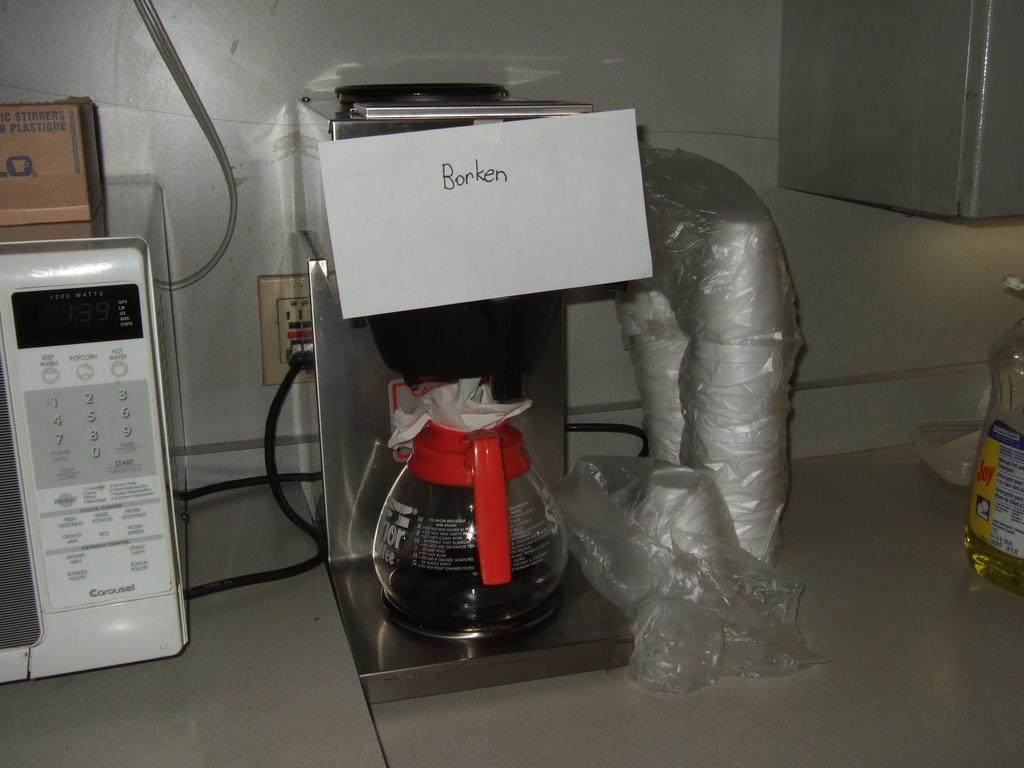What does the sign above the coffee pot say?
Provide a succinct answer. Borken. Some cartoon image?
Give a very brief answer. No. 